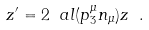<formula> <loc_0><loc_0><loc_500><loc_500>z ^ { \prime } = 2 \ a l ( p ^ { \mu } _ { 3 } n _ { \mu } ) z \ .</formula> 